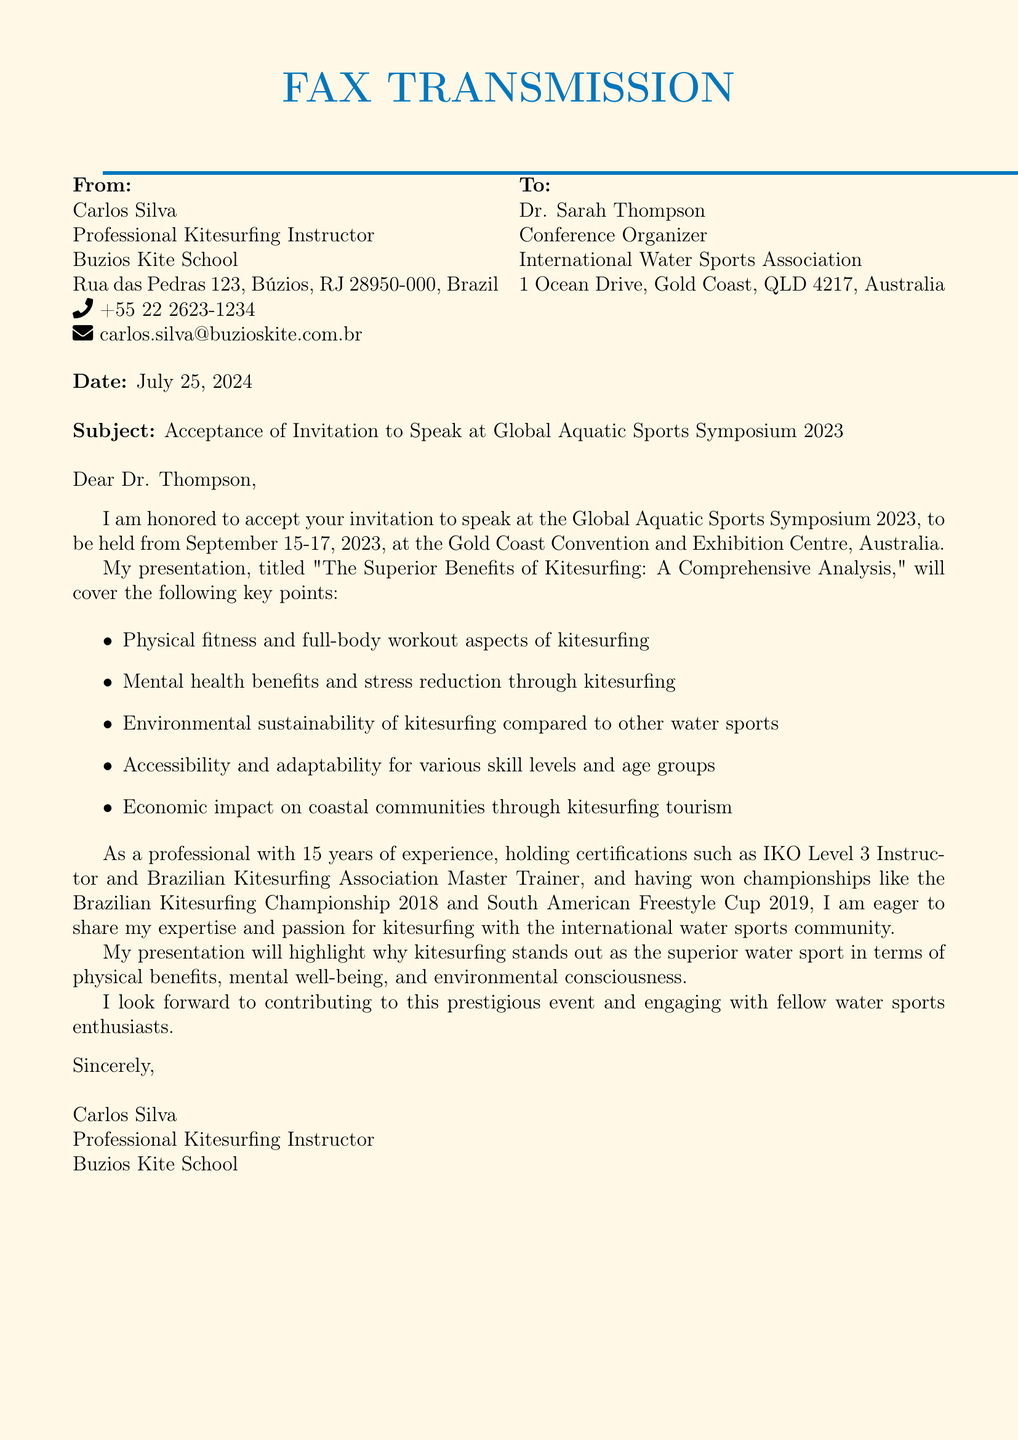What is the name of the conference? The conference mentioned in the document is called the Global Aquatic Sports Symposium 2023.
Answer: Global Aquatic Sports Symposium 2023 What are the dates of the conference? The conference is scheduled to be held from September 15-17, 2023.
Answer: September 15-17, 2023 Who is the recipient of the fax? The recipient of the fax is Dr. Sarah Thompson.
Answer: Dr. Sarah Thompson What is the title of Carlos Silva's presentation? The title of the presentation given by Carlos Silva is "The Superior Benefits of Kitesurfing: A Comprehensive Analysis."
Answer: The Superior Benefits of Kitesurfing: A Comprehensive Analysis What is Carlos Silva's professional title? Carlos Silva is a Professional Kitesurfing Instructor.
Answer: Professional Kitesurfing Instructor How many years of experience does Carlos Silva have? Carlos Silva has 15 years of experience in kitesurfing.
Answer: 15 years What is one of the certifications held by Carlos Silva? One of the certifications held by Carlos Silva is IKO Level 3 Instructor.
Answer: IKO Level 3 Instructor What will Carlos emphasize in his presentation? Carlos will emphasize the physical benefits, mental well-being, and environmental consciousness of kitesurfing in his presentation.
Answer: Physical benefits, mental well-being, and environmental consciousness Which country is the Buzios Kite School located in? The Buzios Kite School is located in Brazil.
Answer: Brazil 